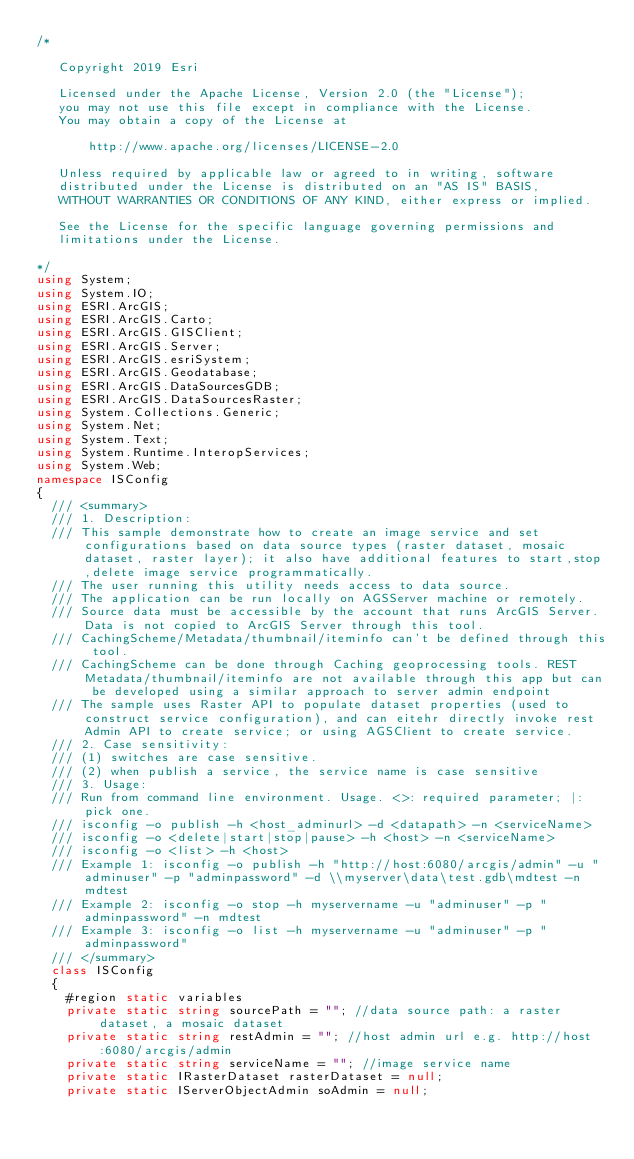Convert code to text. <code><loc_0><loc_0><loc_500><loc_500><_C#_>/*

   Copyright 2019 Esri

   Licensed under the Apache License, Version 2.0 (the "License");
   you may not use this file except in compliance with the License.
   You may obtain a copy of the License at

       http://www.apache.org/licenses/LICENSE-2.0

   Unless required by applicable law or agreed to in writing, software
   distributed under the License is distributed on an "AS IS" BASIS,
   WITHOUT WARRANTIES OR CONDITIONS OF ANY KIND, either express or implied.

   See the License for the specific language governing permissions and
   limitations under the License.

*/
using System;
using System.IO;
using ESRI.ArcGIS;
using ESRI.ArcGIS.Carto;
using ESRI.ArcGIS.GISClient;
using ESRI.ArcGIS.Server;
using ESRI.ArcGIS.esriSystem;
using ESRI.ArcGIS.Geodatabase;
using ESRI.ArcGIS.DataSourcesGDB;
using ESRI.ArcGIS.DataSourcesRaster;
using System.Collections.Generic;
using System.Net;
using System.Text;
using System.Runtime.InteropServices;
using System.Web;
namespace ISConfig
{
  /// <summary>
  /// 1. Description:
  /// This sample demonstrate how to create an image service and set configurations based on data source types (raster dataset, mosaic dataset, raster layer); it also have additional features to start,stop,delete image service programmatically.
  /// The user running this utility needs access to data source.
  /// The application can be run locally on AGSServer machine or remotely.
  /// Source data must be accessible by the account that runs ArcGIS Server. Data is not copied to ArcGIS Server through this tool.
  /// CachingScheme/Metadata/thumbnail/iteminfo can't be defined through this tool.
  /// CachingScheme can be done through Caching geoprocessing tools. REST Metadata/thumbnail/iteminfo are not available through this app but can be developed using a similar approach to server admin endpoint
  /// The sample uses Raster API to populate dataset properties (used to construct service configuration), and can eitehr directly invoke rest Admin API to create service; or using AGSClient to create service.
  /// 2. Case sensitivity:  
  /// (1) switches are case sensitive. 
  /// (2) when publish a service, the service name is case sensitive
  /// 3. Usage:
  /// Run from command line environment. Usage. <>: required parameter; |: pick one.
  /// isconfig -o publish -h <host_adminurl> -d <datapath> -n <serviceName>
  /// isconfig -o <delete|start|stop|pause> -h <host> -n <serviceName>
  /// isconfig -o <list> -h <host>
  /// Example 1: isconfig -o publish -h "http://host:6080/arcgis/admin" -u "adminuser" -p "adminpassword" -d \\myserver\data\test.gdb\mdtest -n mdtest
  /// Example 2: isconfig -o stop -h myservername -u "adminuser" -p "adminpassword" -n mdtest
  /// Example 3: isconfig -o list -h myservername -u "adminuser" -p "adminpassword"
  /// </summary>
  class ISConfig
  {
    #region static variables
    private static string sourcePath = ""; //data source path: a raster dataset, a mosaic dataset
    private static string restAdmin = ""; //host admin url e.g. http://host:6080/arcgis/admin
    private static string serviceName = ""; //image service name        
    private static IRasterDataset rasterDataset = null;
    private static IServerObjectAdmin soAdmin = null;</code> 